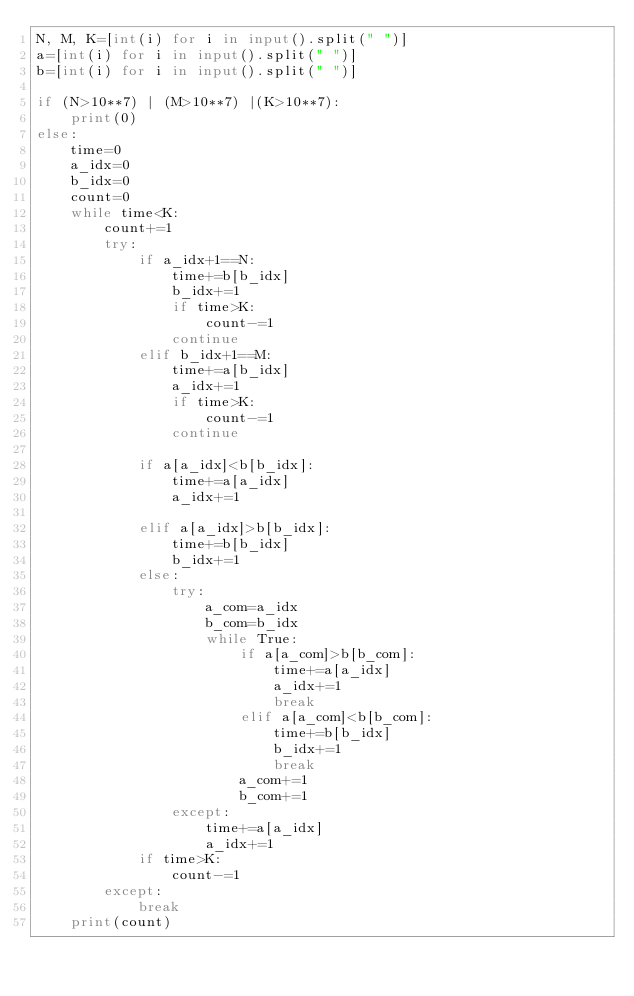<code> <loc_0><loc_0><loc_500><loc_500><_Python_>N, M, K=[int(i) for i in input().split(" ")]
a=[int(i) for i in input().split(" ")]
b=[int(i) for i in input().split(" ")]

if (N>10**7) | (M>10**7) |(K>10**7):
    print(0)
else:
    time=0
    a_idx=0
    b_idx=0
    count=0
    while time<K:
        count+=1
        try:
            if a_idx+1==N:
                time+=b[b_idx]
                b_idx+=1
                if time>K:
                    count-=1
                continue
            elif b_idx+1==M:
                time+=a[b_idx]
                a_idx+=1
                if time>K:
                    count-=1
                continue    

            if a[a_idx]<b[b_idx]:
                time+=a[a_idx]
                a_idx+=1

            elif a[a_idx]>b[b_idx]:
                time+=b[b_idx]
                b_idx+=1
            else:
                try:
                    a_com=a_idx
                    b_com=b_idx
                    while True:
                        if a[a_com]>b[b_com]:
                            time+=a[a_idx]
                            a_idx+=1
                            break
                        elif a[a_com]<b[b_com]:
                            time+=b[b_idx]
                            b_idx+=1
                            break
                        a_com+=1
                        b_com+=1
                except:
                    time+=a[a_idx]
                    a_idx+=1
            if time>K:
                count-=1            
        except:
            break
    print(count)       </code> 